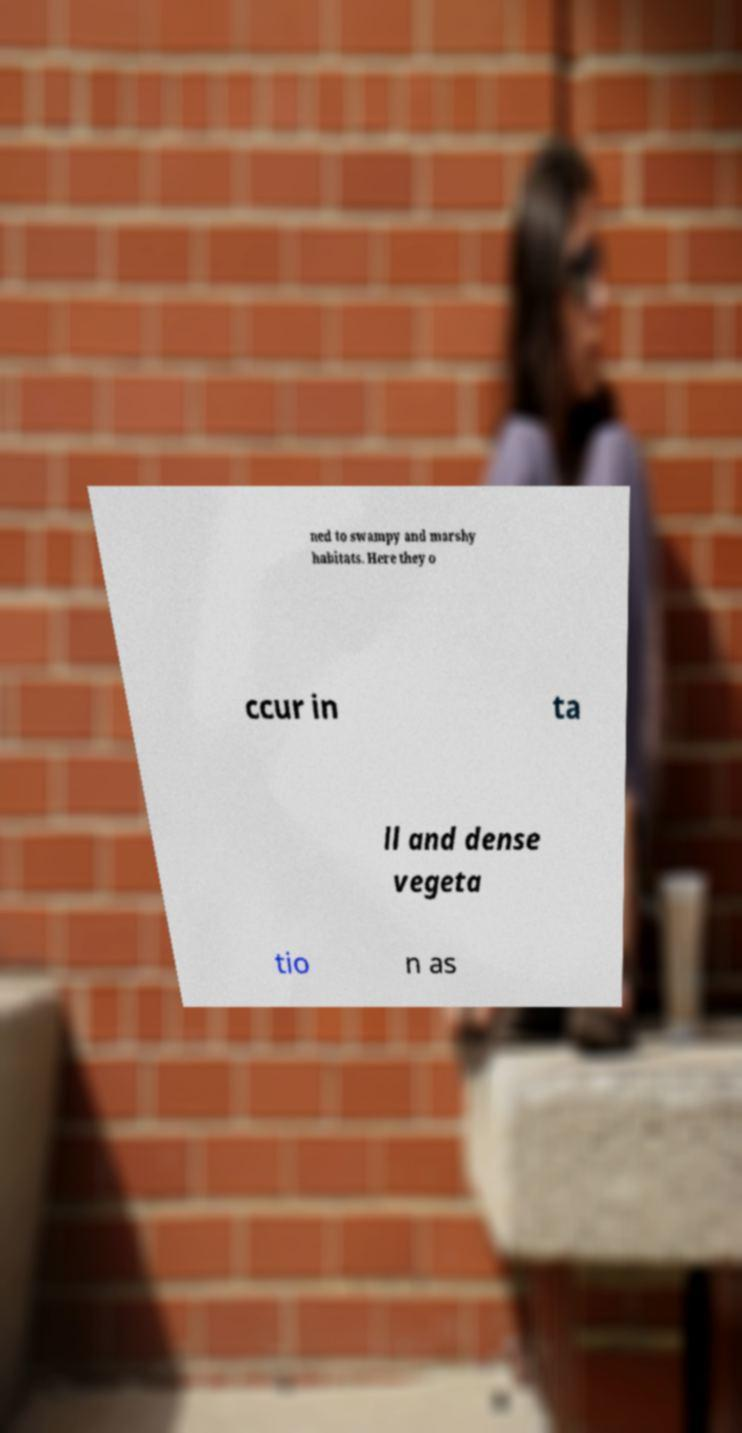Could you extract and type out the text from this image? ned to swampy and marshy habitats. Here they o ccur in ta ll and dense vegeta tio n as 